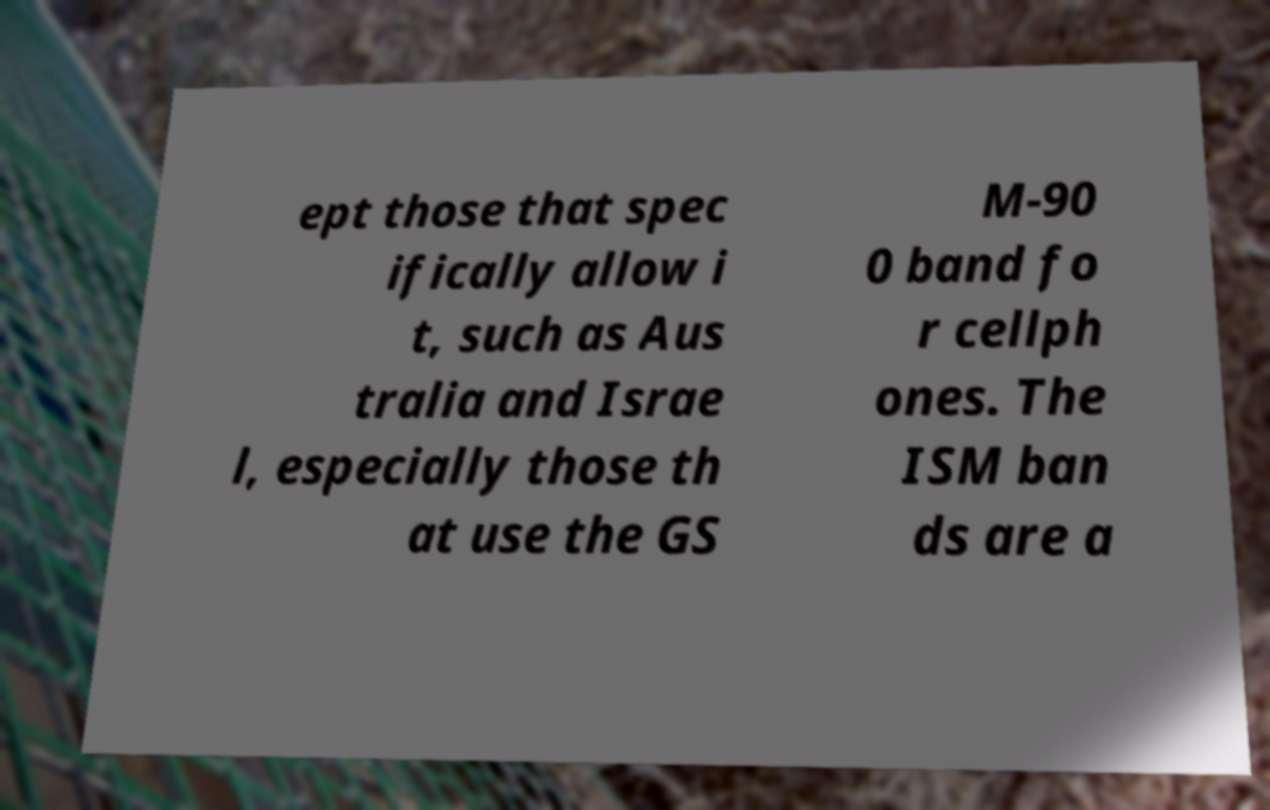Please identify and transcribe the text found in this image. ept those that spec ifically allow i t, such as Aus tralia and Israe l, especially those th at use the GS M-90 0 band fo r cellph ones. The ISM ban ds are a 